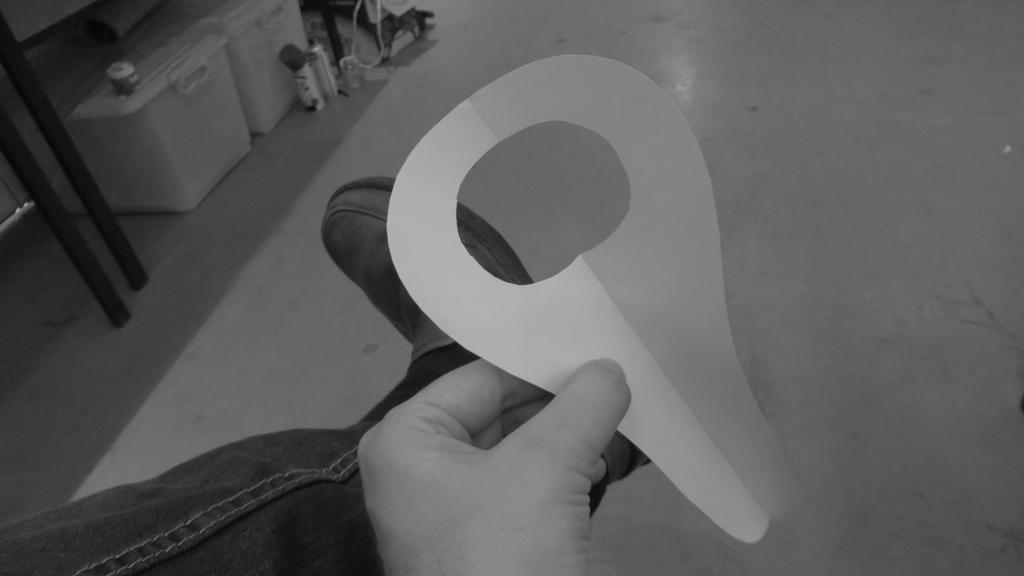In one or two sentences, can you explain what this image depicts? Here in this picture we can see a person holding a piece of paper in hand and in the front we can see some boxes and spray bottles present on the floor. 